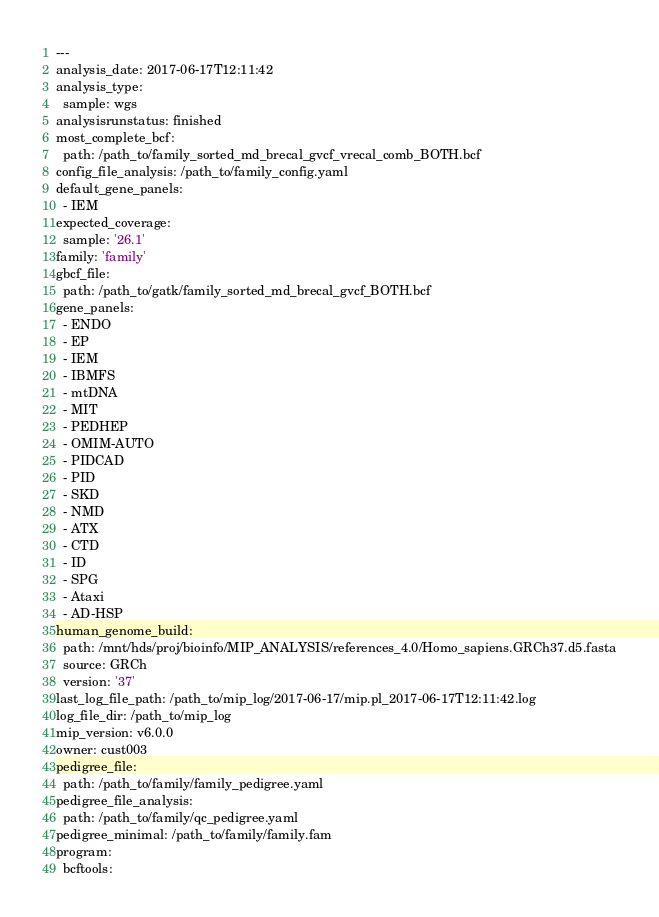<code> <loc_0><loc_0><loc_500><loc_500><_YAML_>---
analysis_date: 2017-06-17T12:11:42
analysis_type:
  sample: wgs
analysisrunstatus: finished
most_complete_bcf:
  path: /path_to/family_sorted_md_brecal_gvcf_vrecal_comb_BOTH.bcf
config_file_analysis: /path_to/family_config.yaml
default_gene_panels:
  - IEM
expected_coverage:
  sample: '26.1'
family: 'family'
gbcf_file:
  path: /path_to/gatk/family_sorted_md_brecal_gvcf_BOTH.bcf
gene_panels:
  - ENDO
  - EP
  - IEM
  - IBMFS
  - mtDNA
  - MIT
  - PEDHEP
  - OMIM-AUTO
  - PIDCAD
  - PID
  - SKD
  - NMD
  - ATX
  - CTD
  - ID
  - SPG
  - Ataxi
  - AD-HSP
human_genome_build:
  path: /mnt/hds/proj/bioinfo/MIP_ANALYSIS/references_4.0/Homo_sapiens.GRCh37.d5.fasta
  source: GRCh
  version: '37'
last_log_file_path: /path_to/mip_log/2017-06-17/mip.pl_2017-06-17T12:11:42.log
log_file_dir: /path_to/mip_log
mip_version: v6.0.0
owner: cust003
pedigree_file:
  path: /path_to/family/family_pedigree.yaml
pedigree_file_analysis:
  path: /path_to/family/qc_pedigree.yaml
pedigree_minimal: /path_to/family/family.fam
program:
  bcftools:</code> 